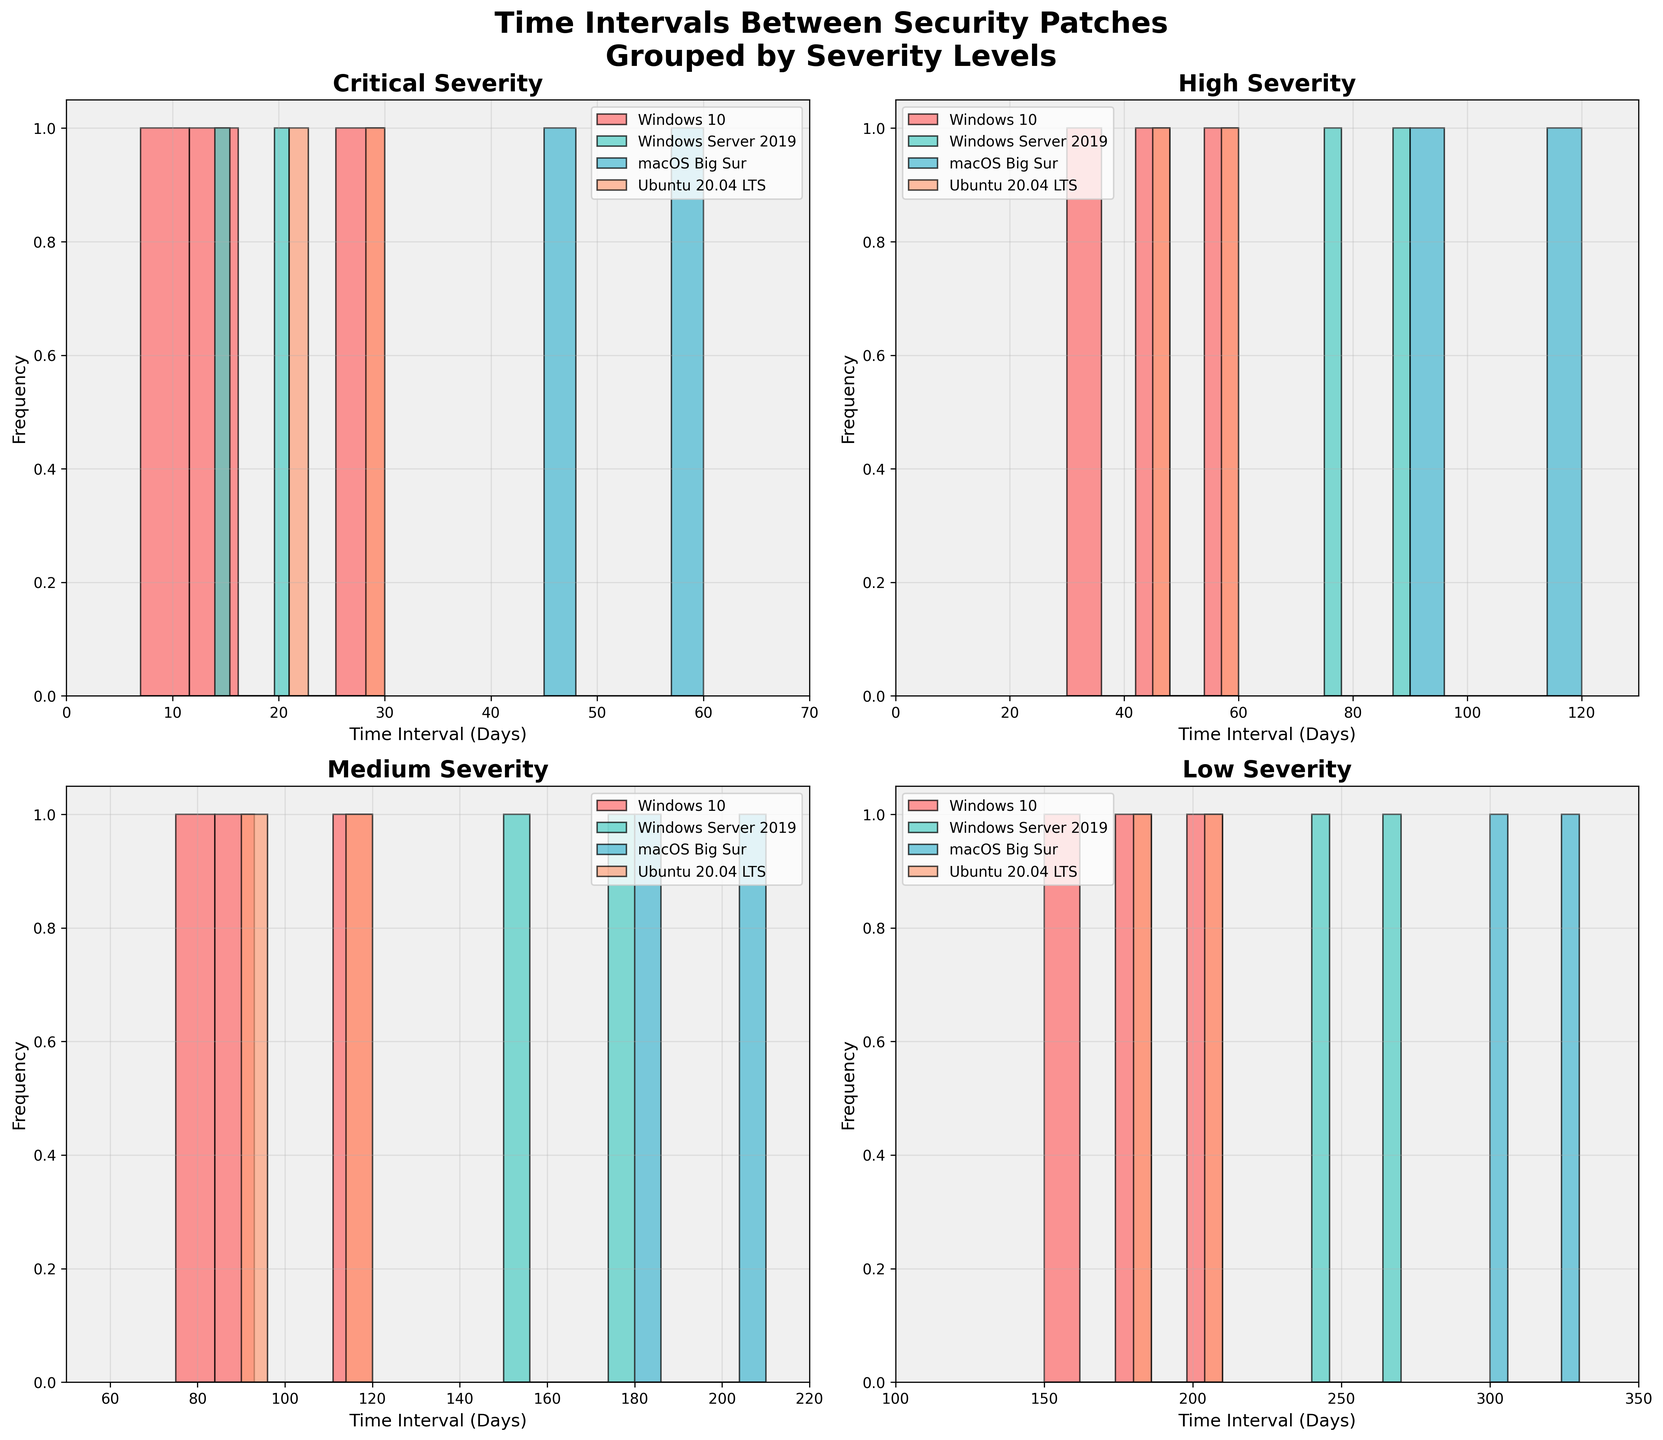What is the title of the figure? The title of the figure is typically placed at the top and provides a summary of what the figure represents. Here, it says "Time Intervals Between Security Patches Grouped by Severity Levels".
Answer: Time Intervals Between Security Patches Grouped by Severity Levels Which severity level has a histogram with the widest spread of time intervals? To find the histogram with the widest spread, look at the x-axis ranges for each subplot. The subplot for "Low" severity has an x-axis range from 100 to 350 days, which is the widest spread among all.
Answer: Low How many operating systems are compared in each histogram? Each histogram compares the same number of operating systems, which are visible in the legend of each subplot. There are four: Windows 10, Windows Server 2019, macOS Big Sur, and Ubuntu 20.04 LTS.
Answer: Four Which operating system has the shortest time interval for 'Critical' severity patches? Look at the histogram for 'Critical' severity and identify the operating systems that show the smallest bins. For 'Critical' severity, Windows 10 has the shortest time interval visible at 7 days.
Answer: Windows 10 What are the bins for Windows Server 2019 under 'High' severity? Observe the histogram for 'High' severity and look at the location of the bins corresponding to Windows Server 2019. They are at 75 days and 90 days.
Answer: 75 days and 90 days Compare the average patching intervals for 'Medium' severity between macOS Big Sur and Ubuntu 20.04 LTS. To find the average patching intervals, look at the centers of the bins for macOS Big Sur (180 and 210 days) and Ubuntu 20.04 LTS (90 and 120 days). Calculate the average of these points. For macOS Big Sur: (180+210)/2 = 195 days. For Ubuntu 20.04 LTS: (90+120)/2 = 105 days.
Answer: macOS Big Sur: 195 days, Ubuntu 20.04 LTS: 105 days Which severity level shows the greatest histogram overlap among the operating systems? Look at the histograms where multiple operating systems share similar bin ranges. 'Critical' severity shows significant overlap as all its intervals are within a 0-60 day range.
Answer: Critical What is the range of time intervals for Windows 10 under 'Medium' severity? Check the 'Medium' severity histogram and locate the bins for Windows 10. The range is from 75 days to 120 days.
Answer: 75 to 120 days How do the median patch intervals for 'High' severity compare between macOS Big Sur and Windows 10? Determine the median by identifying the middle point of each histogram for the specified severity when sorted. For macOS Big Sur (90 and 120 days), median is (90+120)/2 = 105 days. For Windows 10 (30, 45, and 60 days), median is 45 days (middle value).
Answer: macOS Big Sur: 105 days, Windows 10: 45 days Which operating system has the most varied patch intervals for 'Low' severity? Look at 'Low' severity and assess the range of bins for each operating system. macOS Big Sur shows the most varied intervals ranging from 300 to 330 days.
Answer: macOS Big Sur 